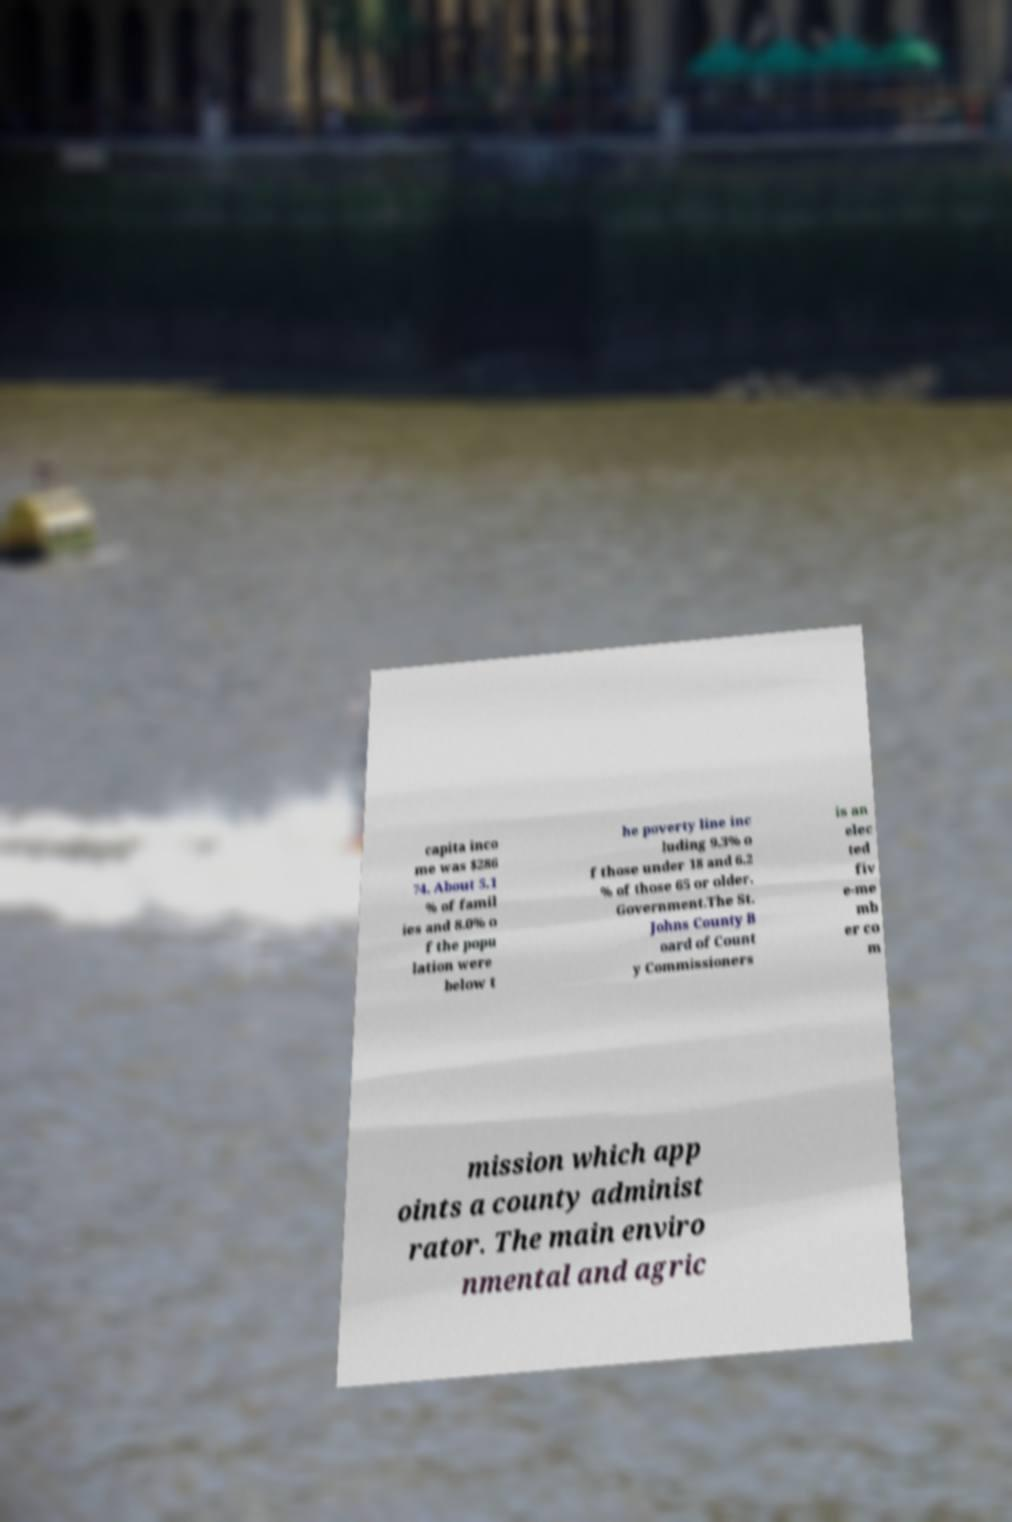There's text embedded in this image that I need extracted. Can you transcribe it verbatim? capita inco me was $286 74. About 5.1 % of famil ies and 8.0% o f the popu lation were below t he poverty line inc luding 9.3% o f those under 18 and 6.2 % of those 65 or older. Government.The St. Johns County B oard of Count y Commissioners is an elec ted fiv e-me mb er co m mission which app oints a county administ rator. The main enviro nmental and agric 